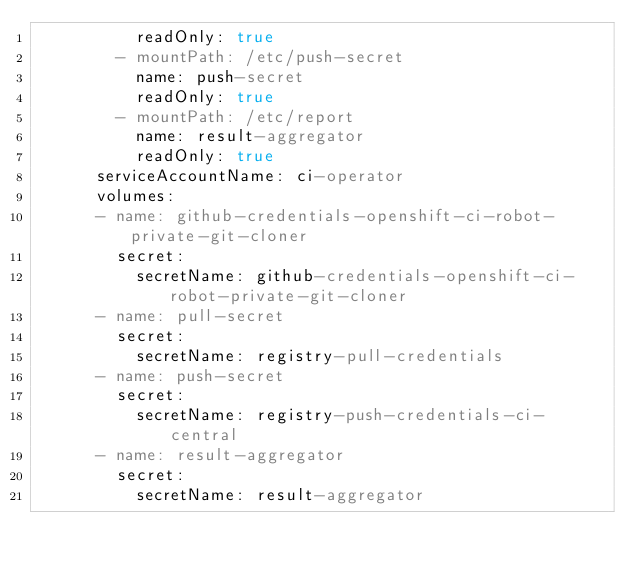Convert code to text. <code><loc_0><loc_0><loc_500><loc_500><_YAML_>          readOnly: true
        - mountPath: /etc/push-secret
          name: push-secret
          readOnly: true
        - mountPath: /etc/report
          name: result-aggregator
          readOnly: true
      serviceAccountName: ci-operator
      volumes:
      - name: github-credentials-openshift-ci-robot-private-git-cloner
        secret:
          secretName: github-credentials-openshift-ci-robot-private-git-cloner
      - name: pull-secret
        secret:
          secretName: registry-pull-credentials
      - name: push-secret
        secret:
          secretName: registry-push-credentials-ci-central
      - name: result-aggregator
        secret:
          secretName: result-aggregator
</code> 